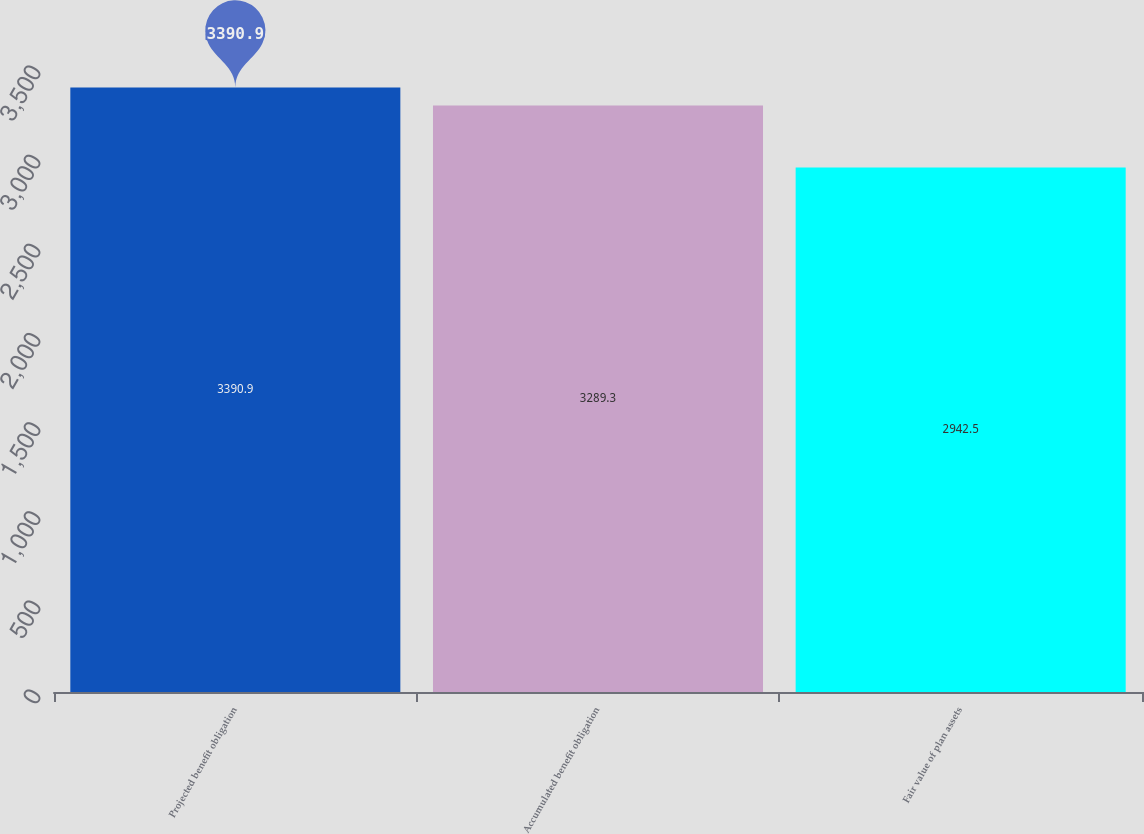<chart> <loc_0><loc_0><loc_500><loc_500><bar_chart><fcel>Projected benefit obligation<fcel>Accumulated benefit obligation<fcel>Fair value of plan assets<nl><fcel>3390.9<fcel>3289.3<fcel>2942.5<nl></chart> 